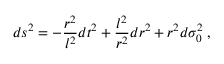<formula> <loc_0><loc_0><loc_500><loc_500>d s ^ { 2 } = - \frac { r ^ { 2 } } { l ^ { 2 } } d t ^ { 2 } + \frac { l ^ { 2 } } { r ^ { 2 } } d r ^ { 2 } + r ^ { 2 } d \sigma _ { 0 } ^ { 2 } \, ,</formula> 